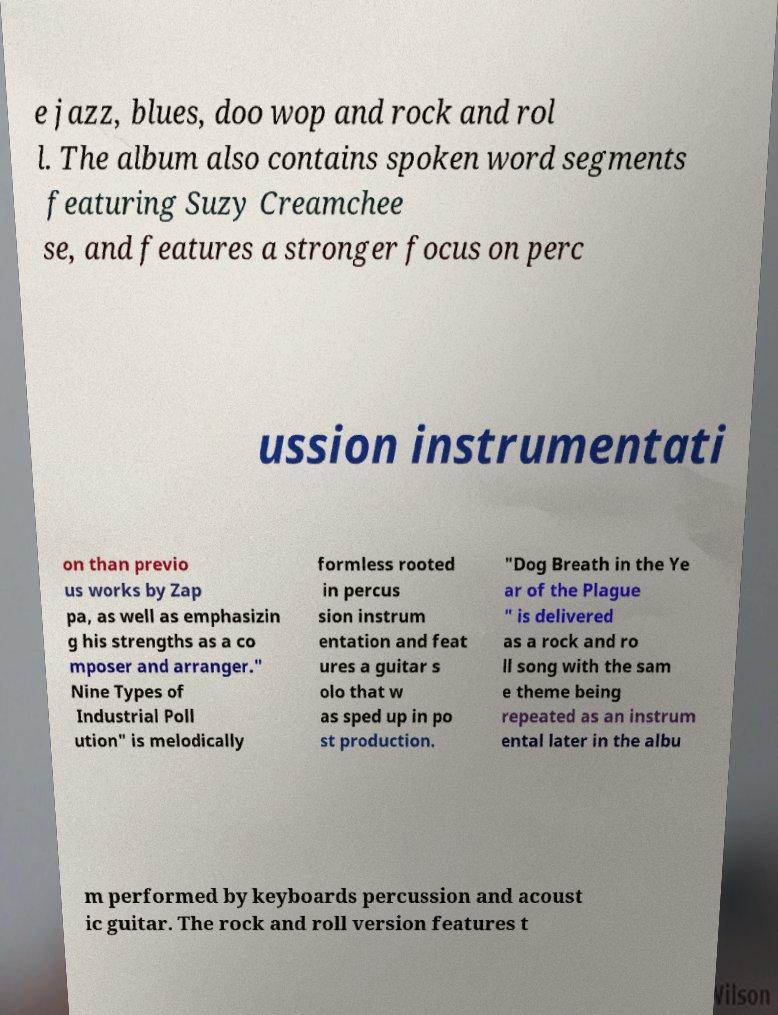I need the written content from this picture converted into text. Can you do that? e jazz, blues, doo wop and rock and rol l. The album also contains spoken word segments featuring Suzy Creamchee se, and features a stronger focus on perc ussion instrumentati on than previo us works by Zap pa, as well as emphasizin g his strengths as a co mposer and arranger." Nine Types of Industrial Poll ution" is melodically formless rooted in percus sion instrum entation and feat ures a guitar s olo that w as sped up in po st production. "Dog Breath in the Ye ar of the Plague " is delivered as a rock and ro ll song with the sam e theme being repeated as an instrum ental later in the albu m performed by keyboards percussion and acoust ic guitar. The rock and roll version features t 